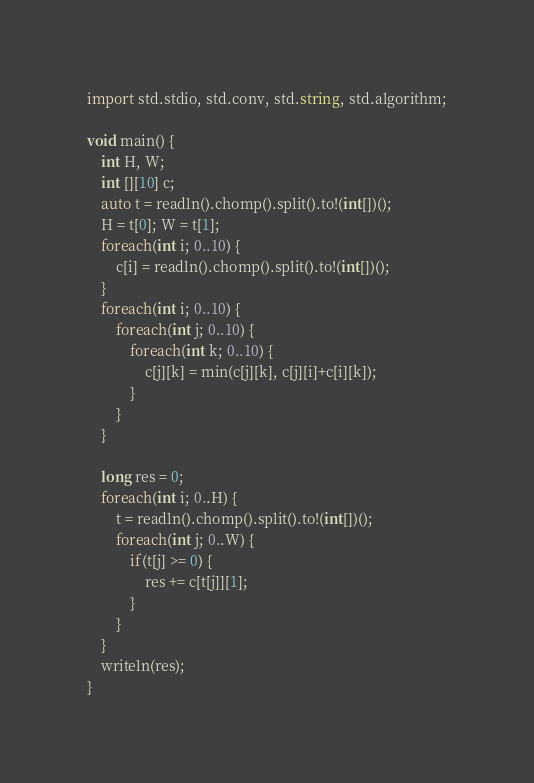<code> <loc_0><loc_0><loc_500><loc_500><_D_>import std.stdio, std.conv, std.string, std.algorithm;

void main() {
	int H, W;
	int [][10] c;
	auto t = readln().chomp().split().to!(int[])();
	H = t[0]; W = t[1];
	foreach(int i; 0..10) {
		c[i] = readln().chomp().split().to!(int[])();
	}
	foreach(int i; 0..10) {
		foreach(int j; 0..10) {
			foreach(int k; 0..10) {
				c[j][k] = min(c[j][k], c[j][i]+c[i][k]);
			}
		}
	}

	long res = 0;
	foreach(int i; 0..H) {
		t = readln().chomp().split().to!(int[])();
		foreach(int j; 0..W) {
			if(t[j] >= 0) {
				res += c[t[j]][1];
			}
		}
	}
	writeln(res);
}
</code> 